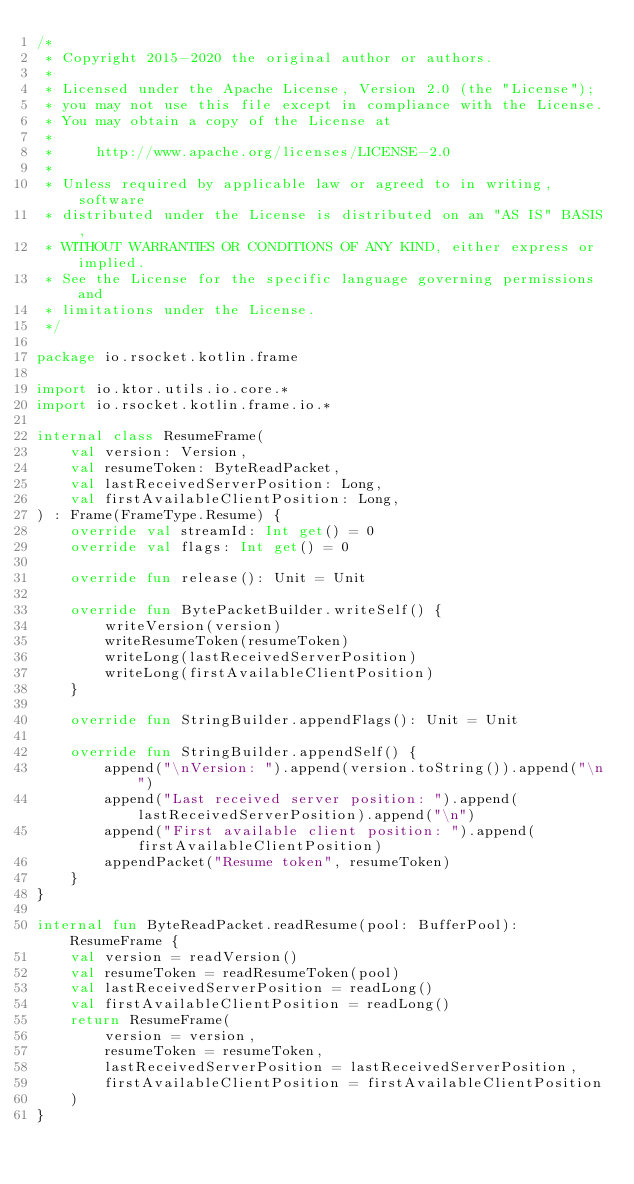<code> <loc_0><loc_0><loc_500><loc_500><_Kotlin_>/*
 * Copyright 2015-2020 the original author or authors.
 *
 * Licensed under the Apache License, Version 2.0 (the "License");
 * you may not use this file except in compliance with the License.
 * You may obtain a copy of the License at
 *
 *     http://www.apache.org/licenses/LICENSE-2.0
 *
 * Unless required by applicable law or agreed to in writing, software
 * distributed under the License is distributed on an "AS IS" BASIS,
 * WITHOUT WARRANTIES OR CONDITIONS OF ANY KIND, either express or implied.
 * See the License for the specific language governing permissions and
 * limitations under the License.
 */

package io.rsocket.kotlin.frame

import io.ktor.utils.io.core.*
import io.rsocket.kotlin.frame.io.*

internal class ResumeFrame(
    val version: Version,
    val resumeToken: ByteReadPacket,
    val lastReceivedServerPosition: Long,
    val firstAvailableClientPosition: Long,
) : Frame(FrameType.Resume) {
    override val streamId: Int get() = 0
    override val flags: Int get() = 0

    override fun release(): Unit = Unit

    override fun BytePacketBuilder.writeSelf() {
        writeVersion(version)
        writeResumeToken(resumeToken)
        writeLong(lastReceivedServerPosition)
        writeLong(firstAvailableClientPosition)
    }

    override fun StringBuilder.appendFlags(): Unit = Unit

    override fun StringBuilder.appendSelf() {
        append("\nVersion: ").append(version.toString()).append("\n")
        append("Last received server position: ").append(lastReceivedServerPosition).append("\n")
        append("First available client position: ").append(firstAvailableClientPosition)
        appendPacket("Resume token", resumeToken)
    }
}

internal fun ByteReadPacket.readResume(pool: BufferPool): ResumeFrame {
    val version = readVersion()
    val resumeToken = readResumeToken(pool)
    val lastReceivedServerPosition = readLong()
    val firstAvailableClientPosition = readLong()
    return ResumeFrame(
        version = version,
        resumeToken = resumeToken,
        lastReceivedServerPosition = lastReceivedServerPosition,
        firstAvailableClientPosition = firstAvailableClientPosition
    )
}
</code> 